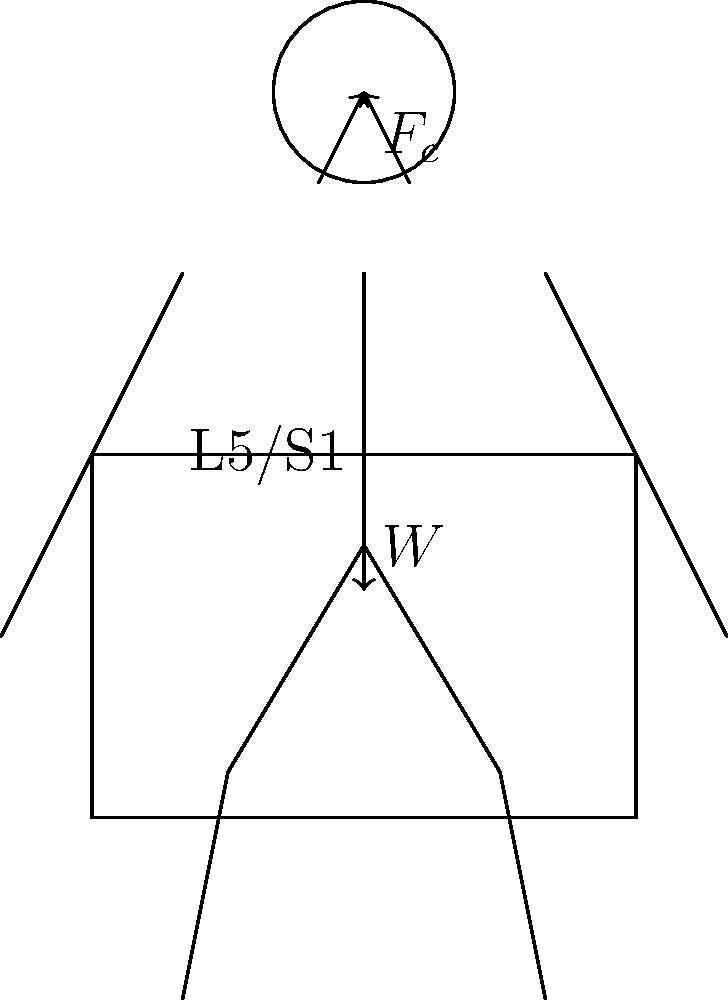When lifting and packing a heavy art piece, you need to evaluate the spinal load at the L5/S1 joint. Using the stick figure model provided, calculate the compression force at the L5/S1 joint if the weight of the art piece is 200 N and the erector spinae muscle force is 2000 N. Assume the perpendicular distance from the L5/S1 joint to the line of action of the erector spinae muscle is 5 cm, and the perpendicular distance from the L5/S1 joint to the center of mass of the upper body and art piece is 20 cm. To calculate the compression force at the L5/S1 joint, we need to consider the forces acting on the joint and use the principle of static equilibrium. Let's follow these steps:

1. Identify the forces acting on the L5/S1 joint:
   - Erector spinae muscle force ($F_c$): 2000 N
   - Weight of the upper body and art piece ($W$): 200 N (art piece) + upper body weight
   - Compression force at L5/S1 joint ($F_{\text{comp}}$): unknown, to be calculated

2. Use the moment equilibrium equation around the L5/S1 joint:
   $$\sum M = 0$$
   $$(F_c \times 0.05) = (W \times 0.20)$$

3. Solve for the total weight ($W$):
   $$W = \frac{F_c \times 0.05}{0.20} = \frac{2000 \times 0.05}{0.20} = 500 \text{ N}$$

4. The total weight includes the art piece (200 N) and the upper body weight:
   Upper body weight = 500 N - 200 N = 300 N

5. Use the vertical force equilibrium equation:
   $$\sum F_y = 0$$
   $$F_{\text{comp}} = F_c + W$$

6. Calculate the compression force:
   $$F_{\text{comp}} = 2000 \text{ N} + 500 \text{ N} = 2500 \text{ N}$$

Therefore, the compression force at the L5/S1 joint is 2500 N.
Answer: 2500 N 